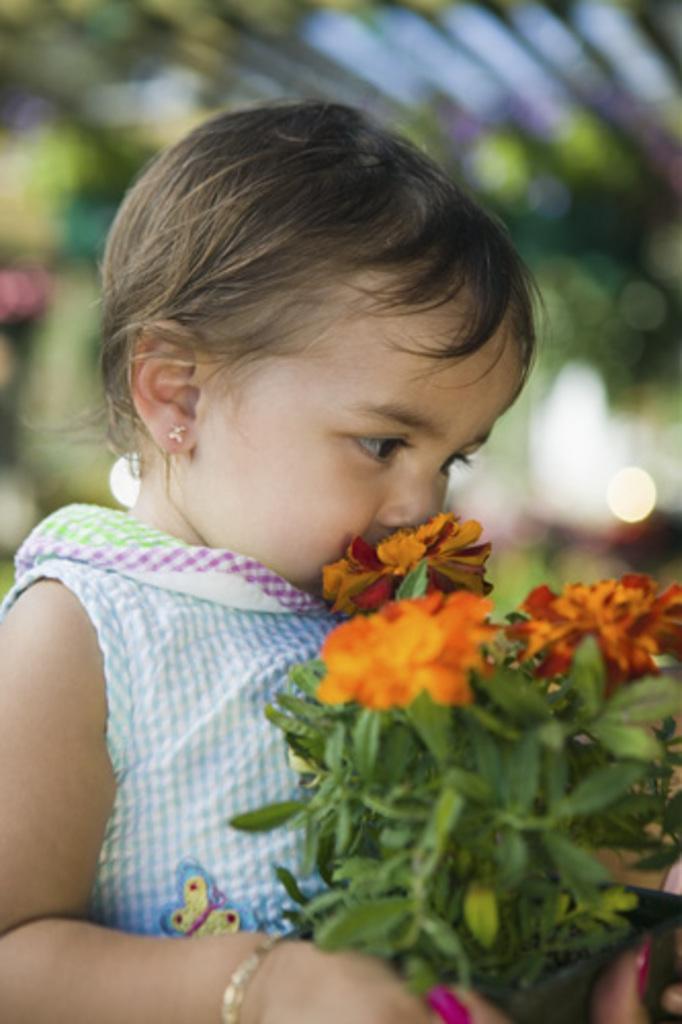How would you summarize this image in a sentence or two? In this image there is a girl holding a book in her hands, in the background it is blurred. 